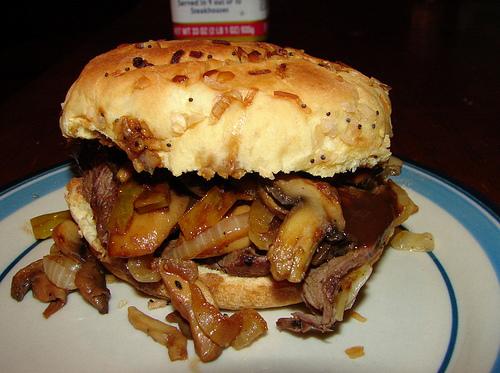Is the burger warm?
Quick response, please. Yes. Is this a vegetarian burger?
Write a very short answer. No. Has any of the food been eaten?
Be succinct. No. 